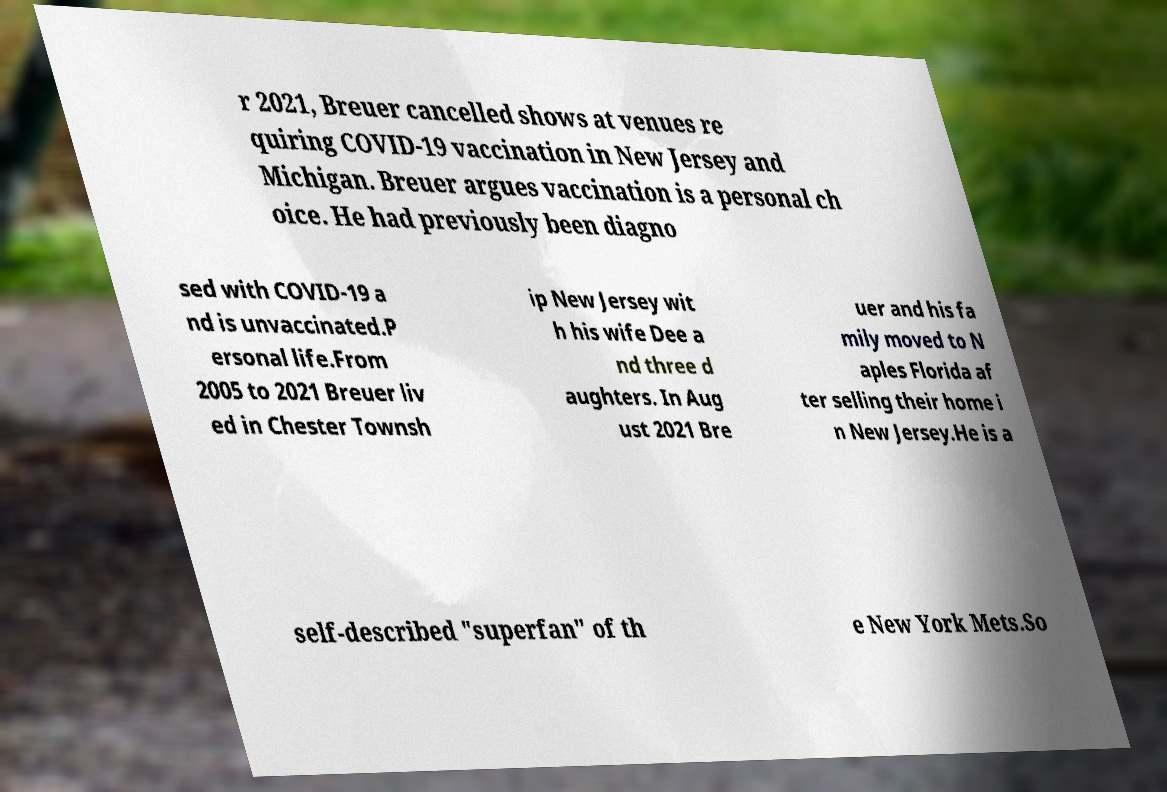Can you read and provide the text displayed in the image?This photo seems to have some interesting text. Can you extract and type it out for me? r 2021, Breuer cancelled shows at venues re quiring COVID-19 vaccination in New Jersey and Michigan. Breuer argues vaccination is a personal ch oice. He had previously been diagno sed with COVID-19 a nd is unvaccinated.P ersonal life.From 2005 to 2021 Breuer liv ed in Chester Townsh ip New Jersey wit h his wife Dee a nd three d aughters. In Aug ust 2021 Bre uer and his fa mily moved to N aples Florida af ter selling their home i n New Jersey.He is a self-described "superfan" of th e New York Mets.So 